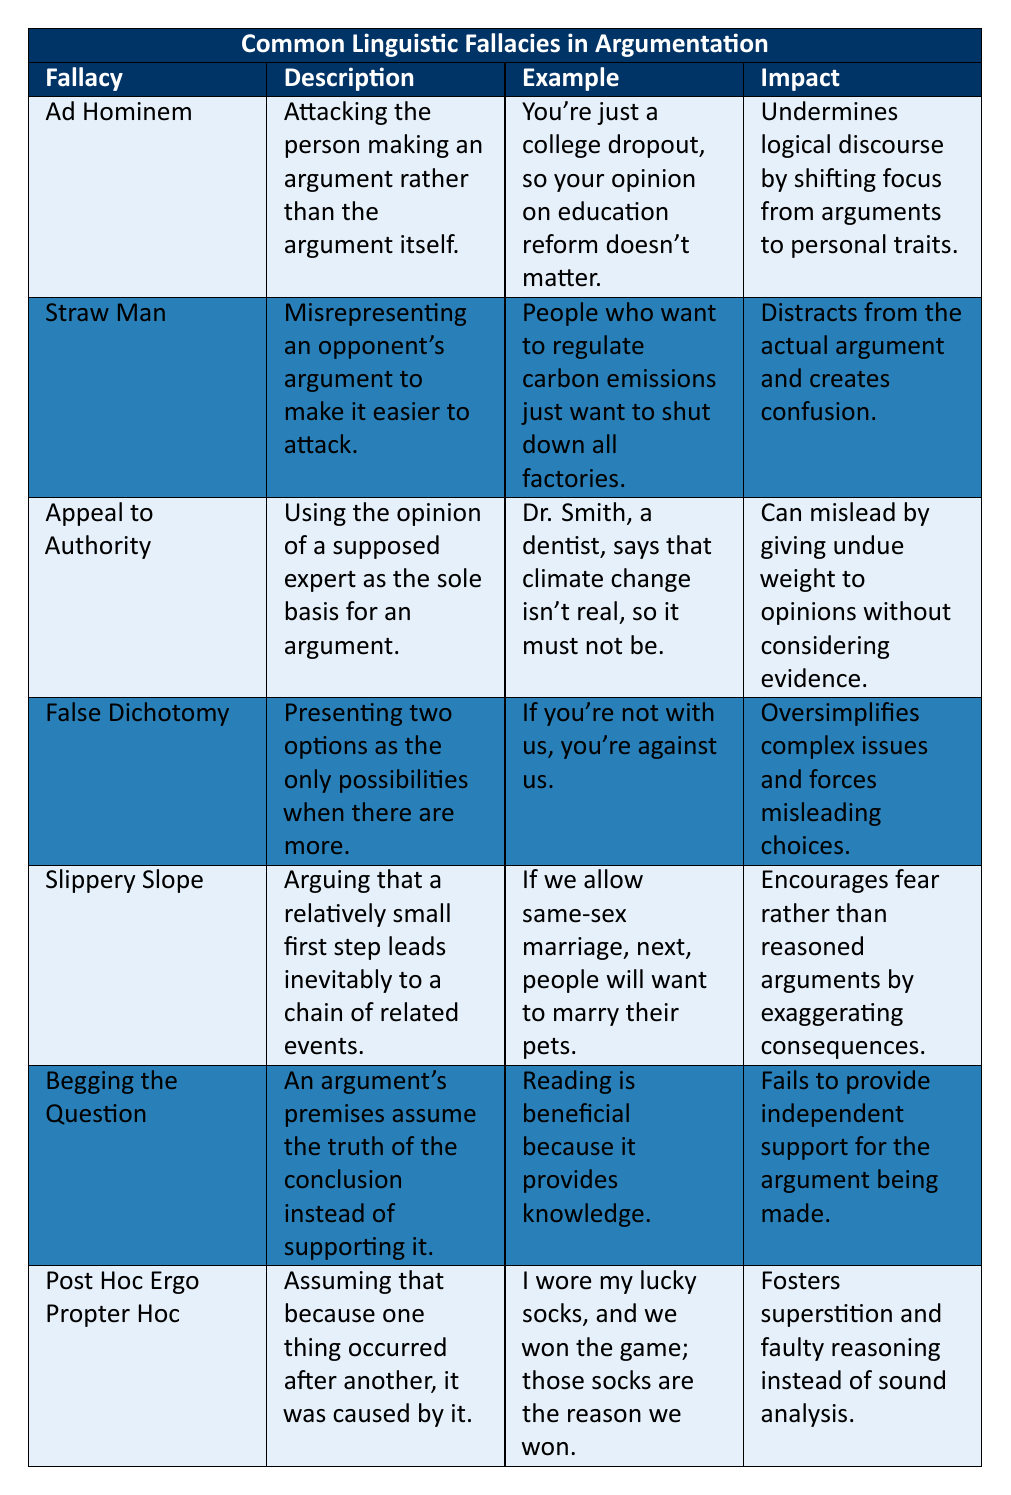What is the description of the "Ad Hominem" fallacy? The description for "Ad Hominem" is: "Attacking the person making an argument rather than the argument itself." This can be found in the description column of the table.
Answer: Attacking the person making an argument rather than the argument itself Give an example of the "Straw Man" fallacy. The example listed for "Straw Man" is: "People who want to regulate carbon emissions just want to shut down all factories." This is directly from the example column of the table.
Answer: People who want to regulate carbon emissions just want to shut down all factories True or false: "Begging the Question" provides independent support for the argument being made. The impact of "Begging the Question" states that it "fails to provide independent support for the argument being made." Therefore, the answer is false.
Answer: False What fallacy is described as presenting two options as the only possibilities when there are more? The fallacy that describes this situation is "False Dichotomy," as indicated in the table. This is found in the fallacy name row and its description column.
Answer: False Dichotomy Which fallacy is characterized by assuming that because one thing occurred after another, it was caused by it? This fallacy is "Post Hoc Ergo Propter Hoc," clearly outlined in the table's description. One can find this detail in the fallacy row in the description column.
Answer: Post Hoc Ergo Propter Hoc What is the impact of the "Slippery Slope" fallacy? The impact of the "Slippery Slope" fallacy, as described in the table, is that it "encourages fear rather than reasoned arguments by exaggerating consequences." This answer can be found in the impact column.
Answer: Encourages fear rather than reasoned arguments by exaggerating consequences List the linguistic fallacies in the table that are described as misleading arguments. The fallacies described as misleading arguments are "Appeal to Authority," "False Dichotomy," and "Post Hoc Ergo Propter Hoc." This requires scanning through the descriptions and impacts to identify which ones focus on misleading reasoning or interpretations.
Answer: Appeal to Authority, False Dichotomy, Post Hoc Ergo Propter Hoc What is the example given for the "False Dichotomy" fallacy? The example for "False Dichotomy" is: "If you're not with us, you're against us." This information is readily available in the example column specific to "False Dichotomy."
Answer: If you're not with us, you're against us 